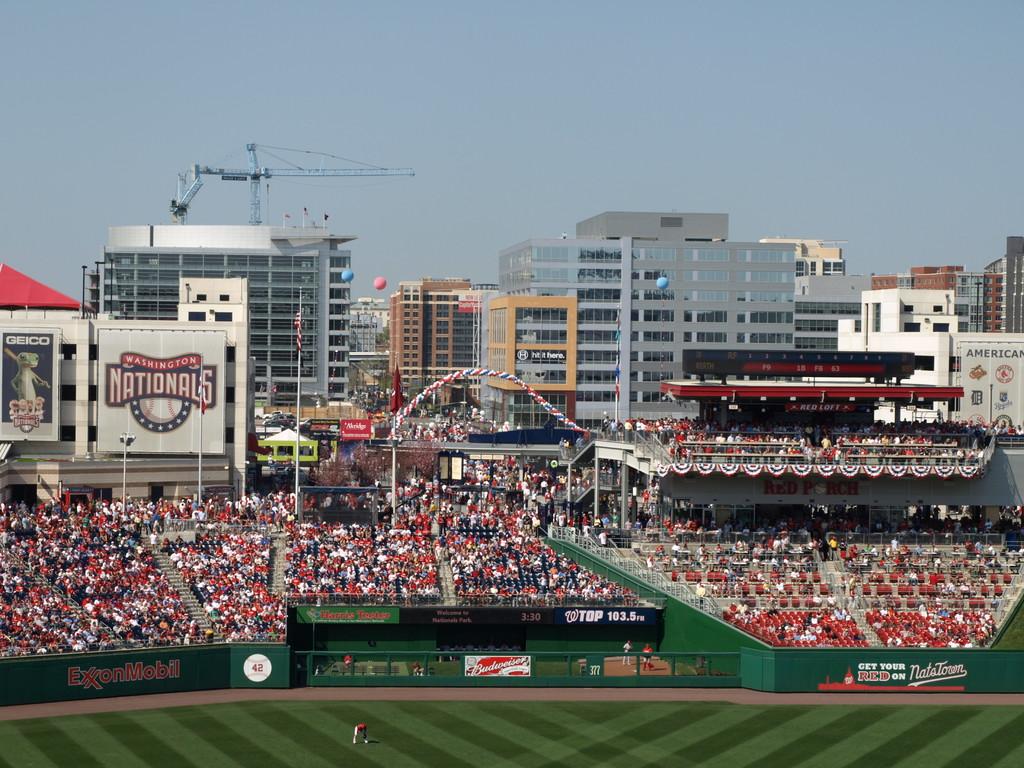What is one of the brands on the walls of the stands?
Ensure brevity in your answer.  Budweiser. What mlb team plays here?
Your response must be concise. Washington nationals. 